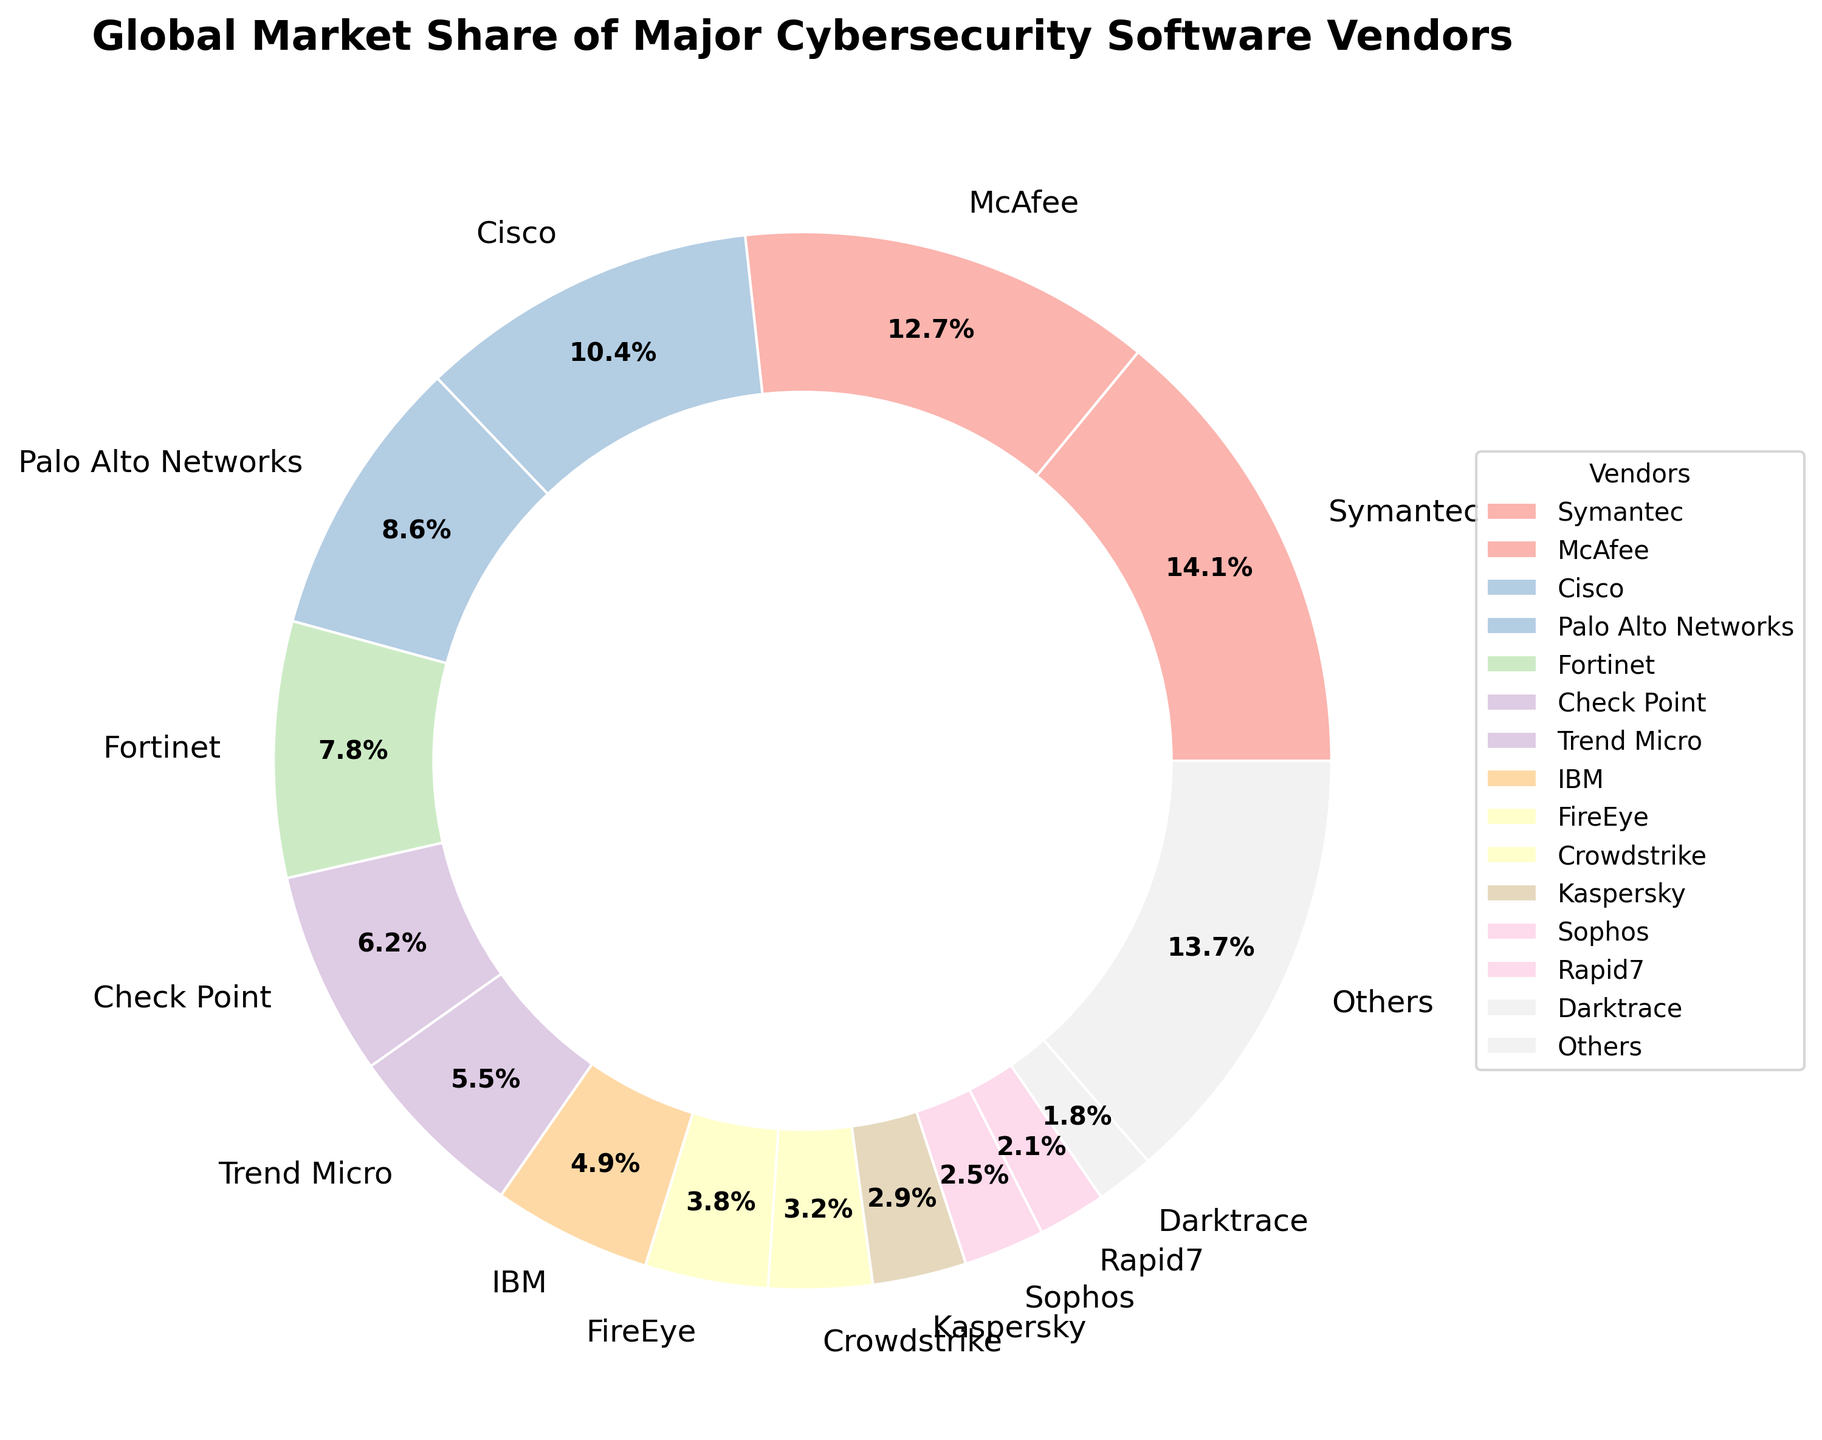What is the market share of the largest cybersecurity software vendor? Look at the pie chart and identify the segment with the largest size. Symantec has the largest segment with a market share of 14.2%.
Answer: 14.2% Which vendor has a larger market share: Cisco or Palo Alto Networks? Compare the sizes of the Cisco and Palo Alto Networks segments in the chart. Cisco has a market share of 10.5%, and Palo Alto Networks has a market share of 8.7%.
Answer: Cisco How much larger is Symantec's market share compared to McAfee's? Subtract McAfee's market share from Symantec's market share: 14.2% - 12.8% = 1.4%.
Answer: 1.4% Is Crowstrike's market share greater than FireEye's? Compare the sizes of the Crowdstrike and FireEye segments. Crowdstrike has a market share of 3.2%, while FireEye has a market share of 3.8%.
Answer: No What is the combined market share of Trend Micro, IBM, and FireEye? Add the market shares of Trend Micro (5.6%), IBM (4.9%), and FireEye (3.8%): 5.6% + 4.9% + 3.8% = 14.3%.
Answer: 14.3% How much market share is held by vendors other than Symantec, McAfee, and Cisco? Subtract the combined market share of Symantec (14.2%), McAfee (12.8%), and Cisco (10.5%) from 100%: 100% - (14.2% + 12.8% + 10.5%) = 62.5%.
Answer: 62.5% Which vendor holds the smallest market share and what is the value? Identify the segment with the smallest size. Darktrace holds the smallest market share of 1.8%.
Answer: Darktrace, 1.8% What percentage of the market is captured by vendors with a market share less than 5%? Add the market shares of vendors with less than 5%: IBM (4.9%), FireEye (3.8%), Crowdstrike (3.2%), Kaspersky (2.9%), Sophos (2.5%), and Rapid7 (2.1%): 4.9% + 3.8% + 3.2% + 2.9% + 2.5% + 2.1% = 19.4%.
Answer: 19.4% Among the vendors with a market share greater than 10%, which one has the second-largest share? Identify vendors with more than 10% market share: Symantec (14.2%) and McAfee (12.8%). Hence, McAfee has the second-largest share.
Answer: McAfee 